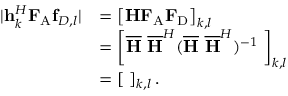<formula> <loc_0><loc_0><loc_500><loc_500>\begin{array} { r l } { | { h } _ { k } ^ { H } { F } _ { A } { f } _ { D , l } | } & { = \left [ { H } { F } _ { A } { F } _ { D } \right ] _ { k , l } } \\ & { = \left [ { \overline { H } } \ { \overline { H } } ^ { H } ( { \overline { H } } \ { \overline { H } } ^ { H } ) ^ { - 1 } { \Lambda } \right ] _ { k , l } } \\ & { = \left [ { \Lambda } \right ] _ { k , l } . } \end{array}</formula> 